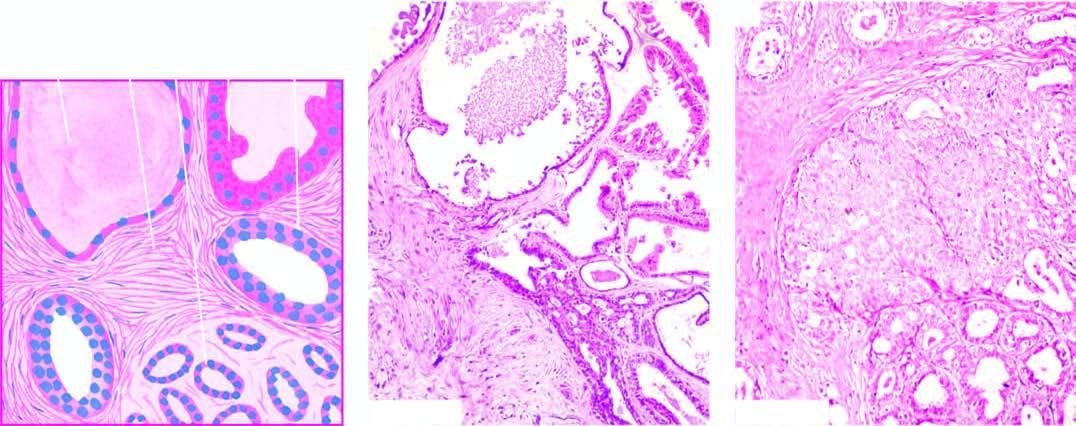what is there in terminal ducts?
Answer the question using a single word or phrase. Mild epithelial hyperplasia 